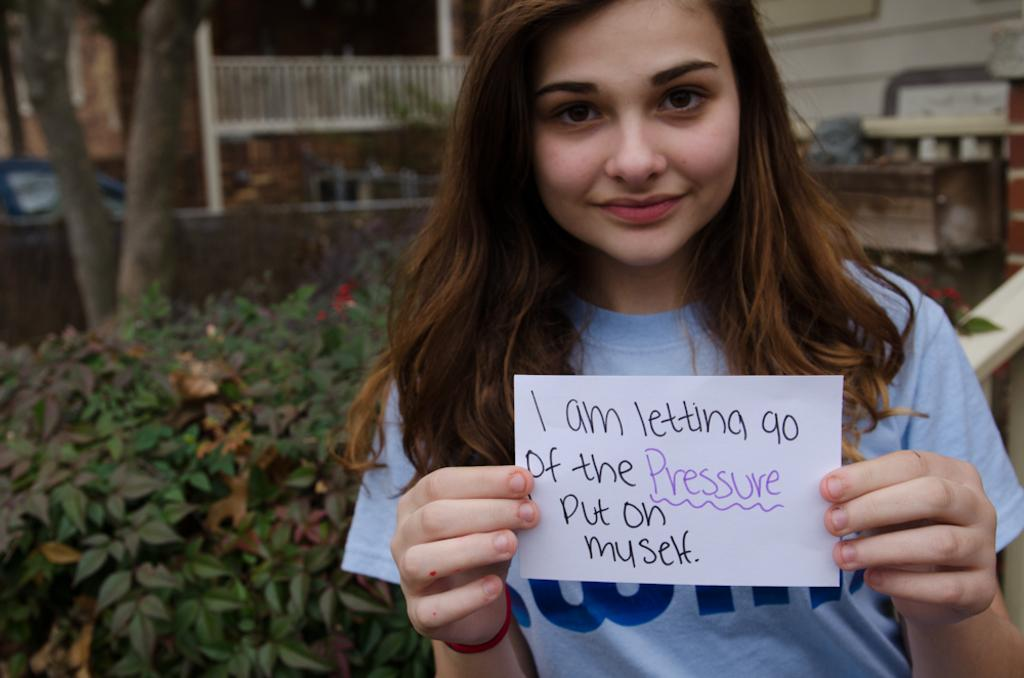Who is present in the image? There is a lady in the image. What is the lady holding in the image? The lady is holding a paper. What can be seen on the paper? There is written on the paper. What can be seen in the background of the image? There are plants, trees, and buildings in the background of the image. What grade did the lady receive on the example paper in the image? There is no grade mentioned on the paper, and there is no indication that the paper is an example. Additionally, there is no grade visible in the image. 